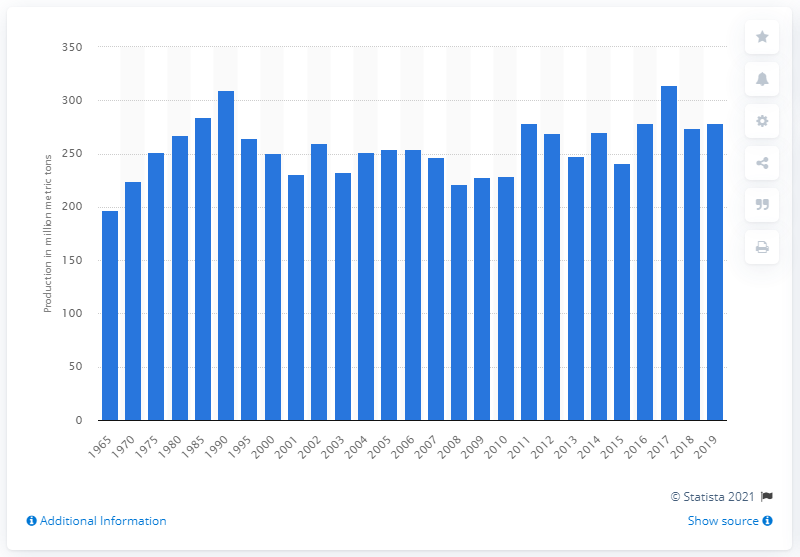What might have caused the fluctuations in production levels over the years? The fluctuations in sugar beet production levels can be attributed to a combination of factors including climate conditions, changes in agricultural technology, shifts in global demand for sugar, market prices, and policy changes. Weather events, such as droughts or excess rainfall, can affect crop yields. Technological advancements can improve crop production efficiency. Additionally, changes in trade policies or the emergence of alternative sweeteners can impact the market for sugar beets. 